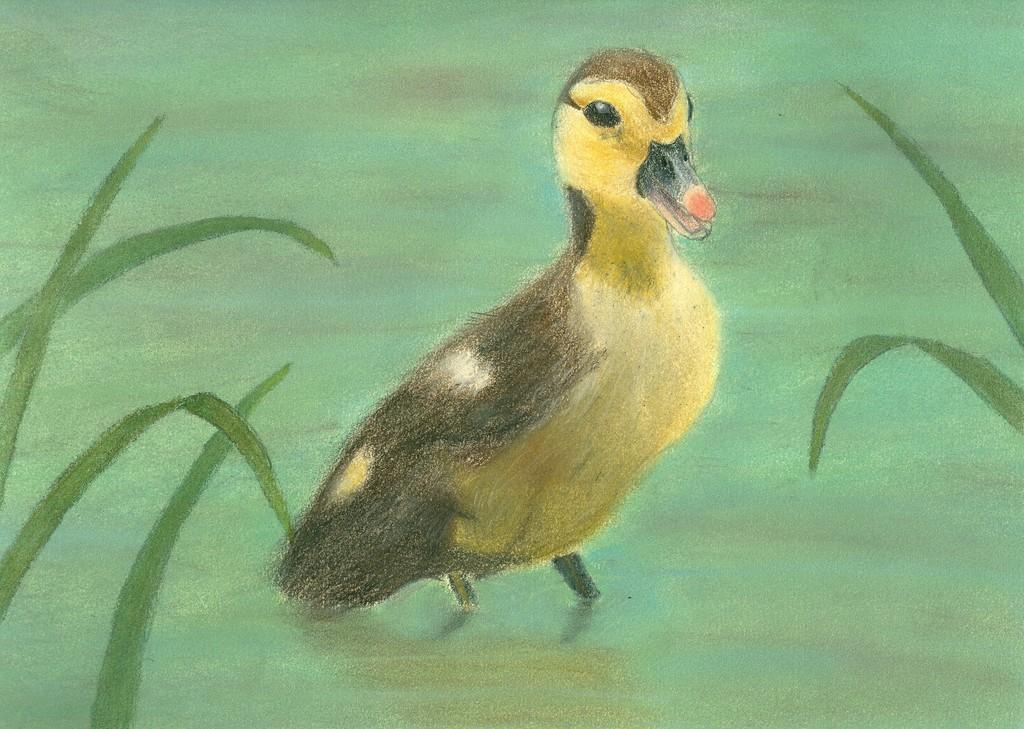Could you give a brief overview of what you see in this image? In this picture we can see a painting of a bird and leaves. 